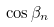<formula> <loc_0><loc_0><loc_500><loc_500>\cos \beta _ { n }</formula> 